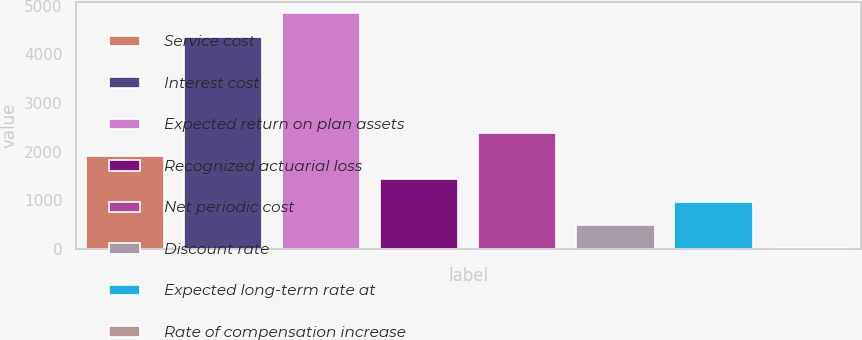<chart> <loc_0><loc_0><loc_500><loc_500><bar_chart><fcel>Service cost<fcel>Interest cost<fcel>Expected return on plan assets<fcel>Recognized actuarial loss<fcel>Net periodic cost<fcel>Discount rate<fcel>Expected long-term rate at<fcel>Rate of compensation increase<nl><fcel>1911.2<fcel>4365<fcel>4841.8<fcel>1434.4<fcel>2388<fcel>480.8<fcel>957.6<fcel>4<nl></chart> 